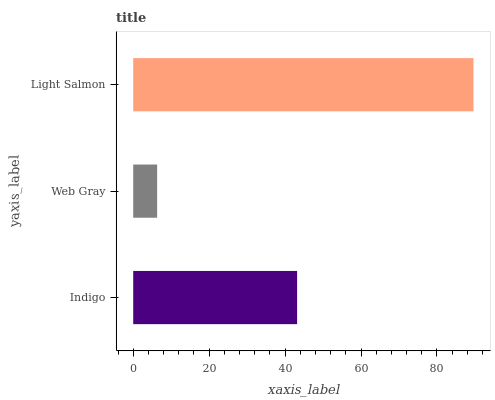Is Web Gray the minimum?
Answer yes or no. Yes. Is Light Salmon the maximum?
Answer yes or no. Yes. Is Light Salmon the minimum?
Answer yes or no. No. Is Web Gray the maximum?
Answer yes or no. No. Is Light Salmon greater than Web Gray?
Answer yes or no. Yes. Is Web Gray less than Light Salmon?
Answer yes or no. Yes. Is Web Gray greater than Light Salmon?
Answer yes or no. No. Is Light Salmon less than Web Gray?
Answer yes or no. No. Is Indigo the high median?
Answer yes or no. Yes. Is Indigo the low median?
Answer yes or no. Yes. Is Light Salmon the high median?
Answer yes or no. No. Is Light Salmon the low median?
Answer yes or no. No. 